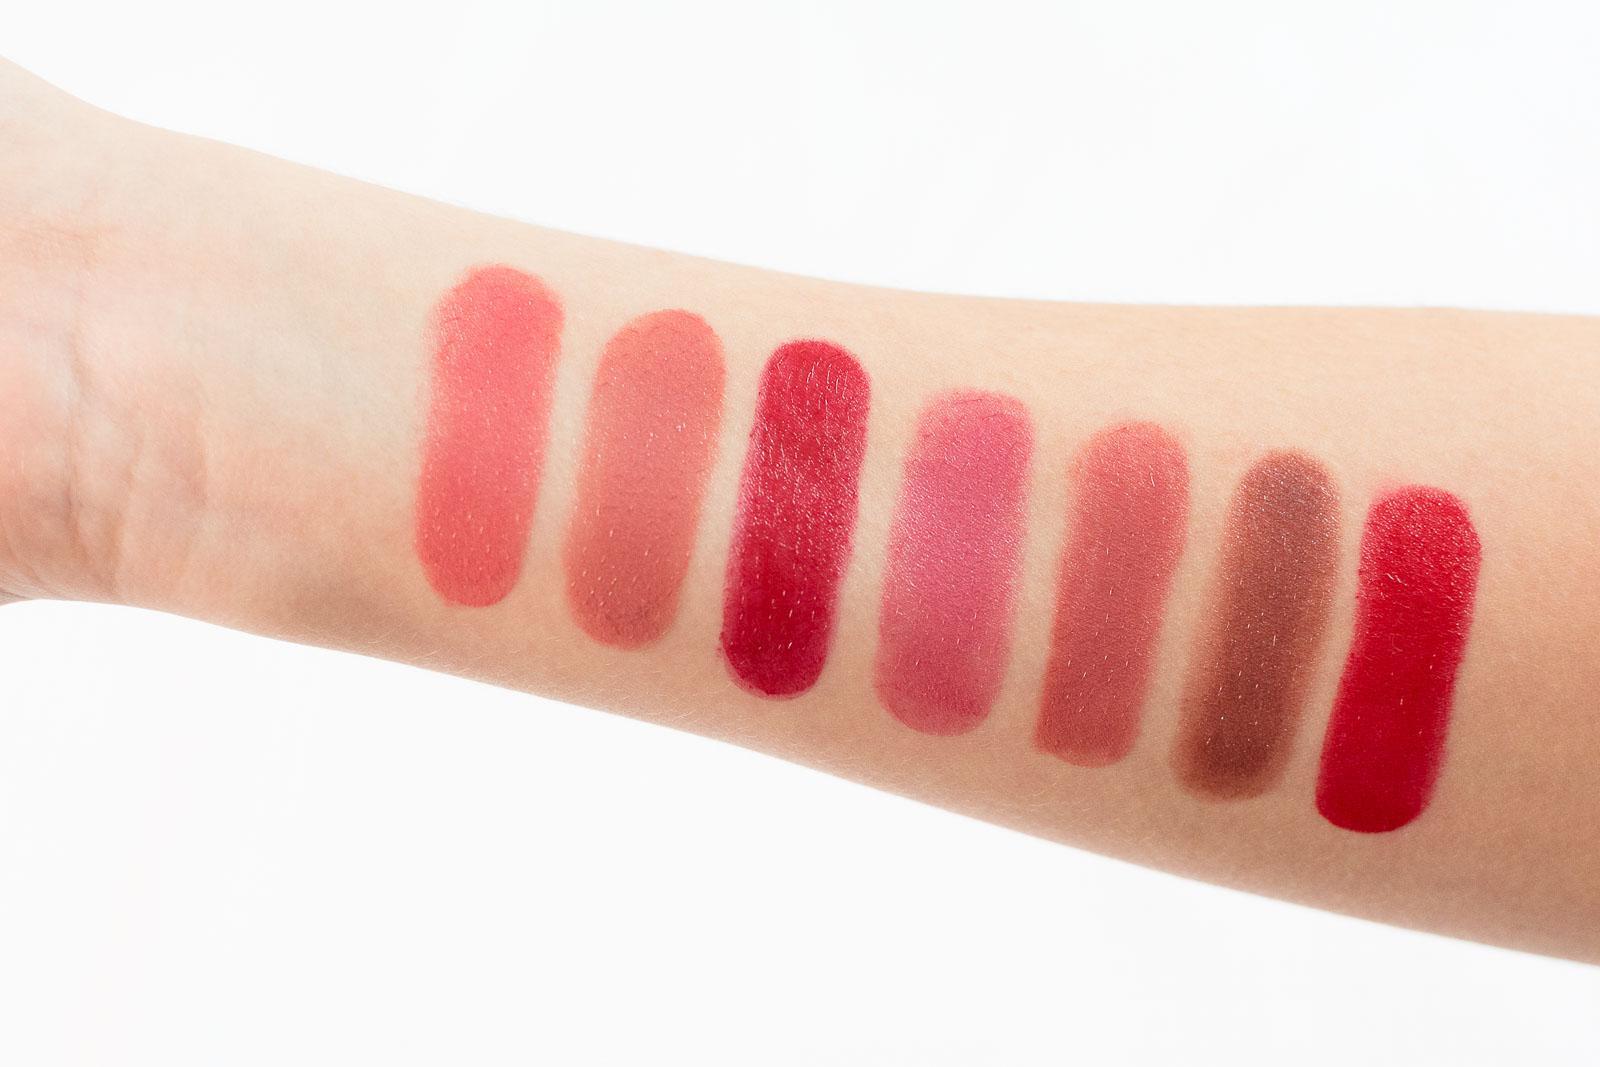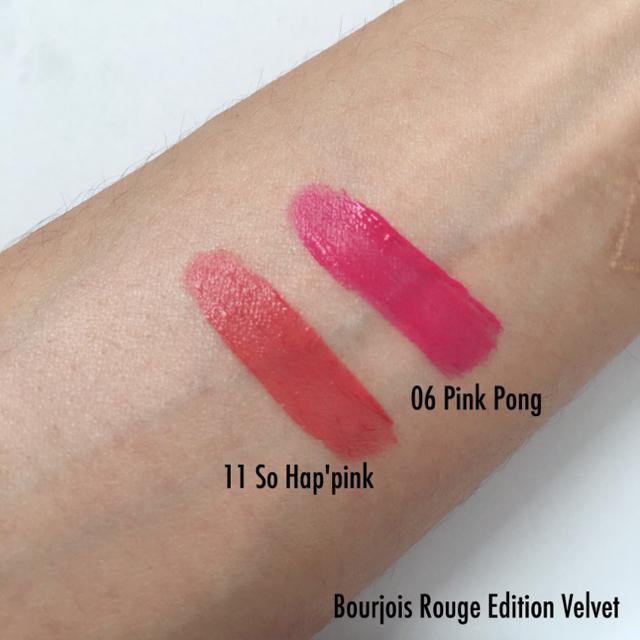The first image is the image on the left, the second image is the image on the right. Given the left and right images, does the statement "There are two lipstick stripes on the skin in one of the images." hold true? Answer yes or no. Yes. The first image is the image on the left, the second image is the image on the right. Analyze the images presented: Is the assertion "An image shows exactly two lipstick smears on a closed fist with pale skin." valid? Answer yes or no. No. 